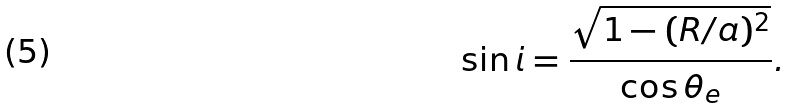Convert formula to latex. <formula><loc_0><loc_0><loc_500><loc_500>\sin i = \frac { \sqrt { 1 - ( R / a ) ^ { 2 } } } { \cos \theta _ { e } } .</formula> 